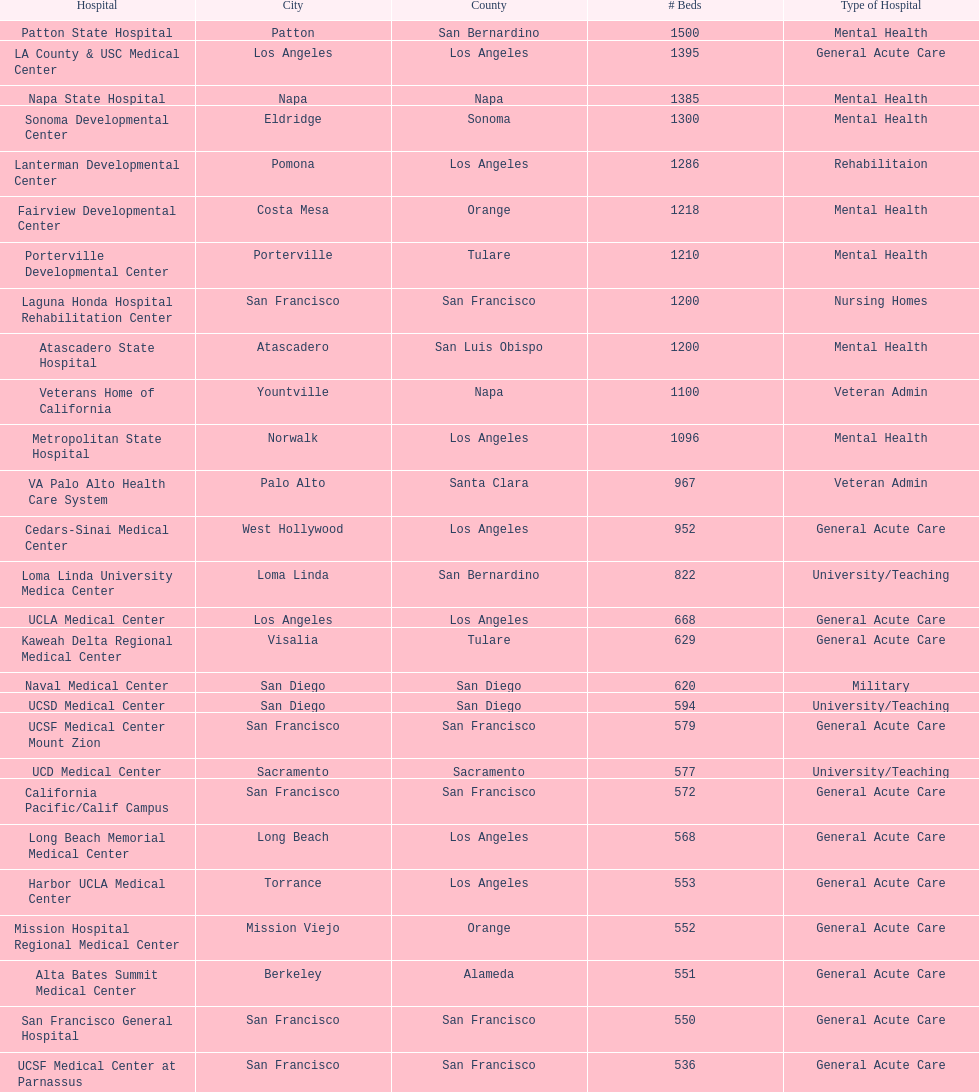How many hospitals have at least 1,000 beds? 11. 